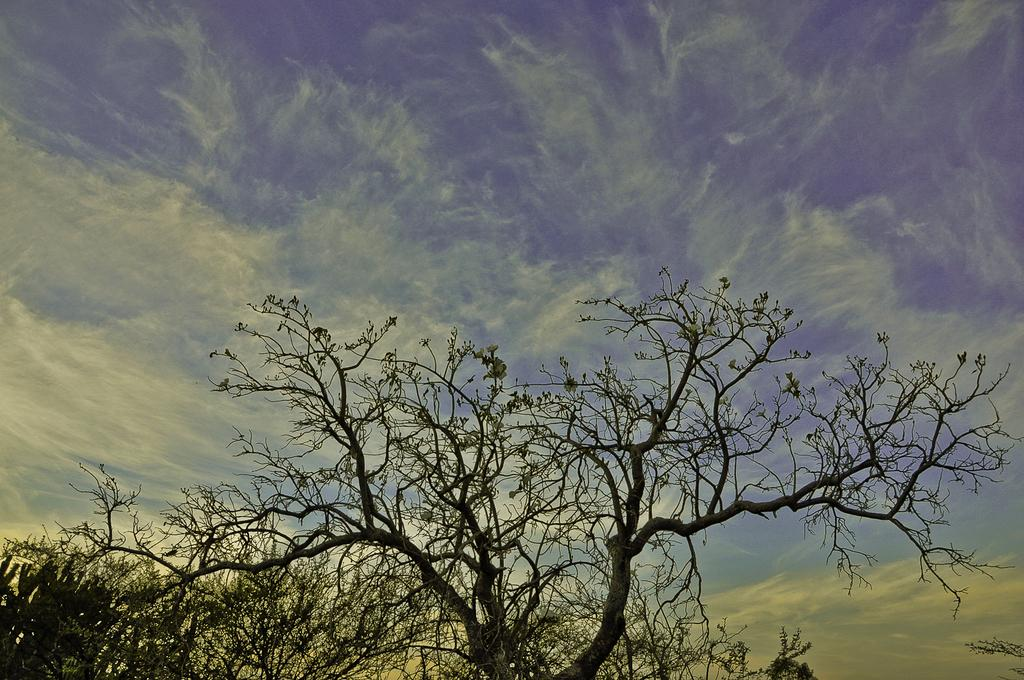What type of vegetation can be seen in the image? There are trees in the image. What part of the natural environment is visible in the image? The sky is visible in the image. What can be observed in the sky? Clouds are present in the sky. What type of oil can be seen dripping from the trees in the image? There is no oil present in the image; it features trees and a sky with clouds. In which direction is the image facing, north or south? The image does not indicate a specific direction, such as north or south. 